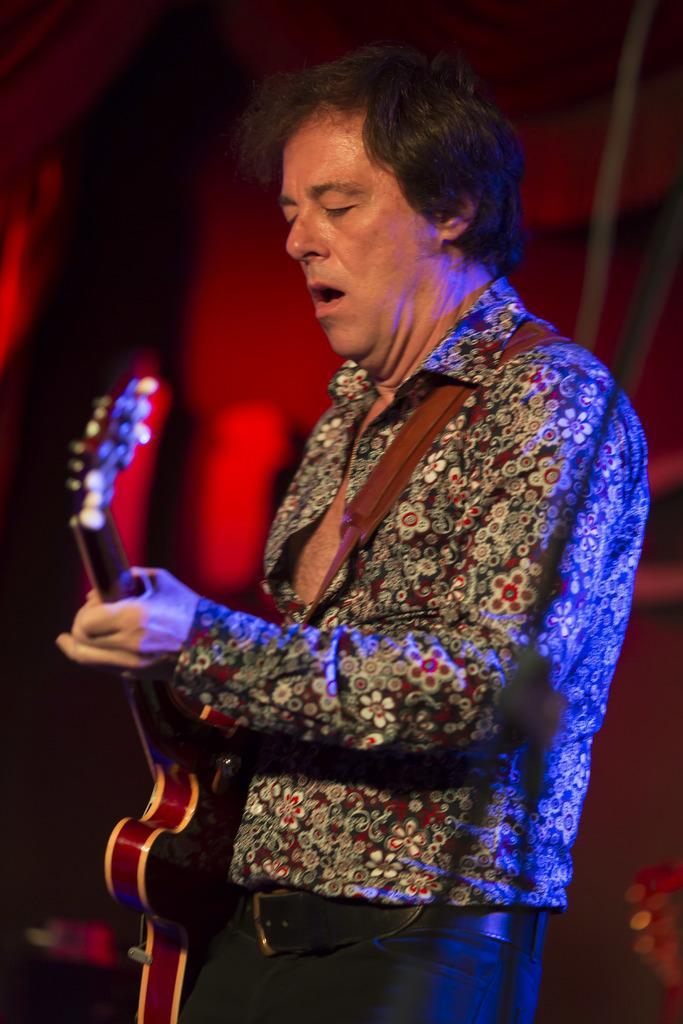Could you give a brief overview of what you see in this image? In the image we can see there is a man who is standing with a guitar in his hand. 